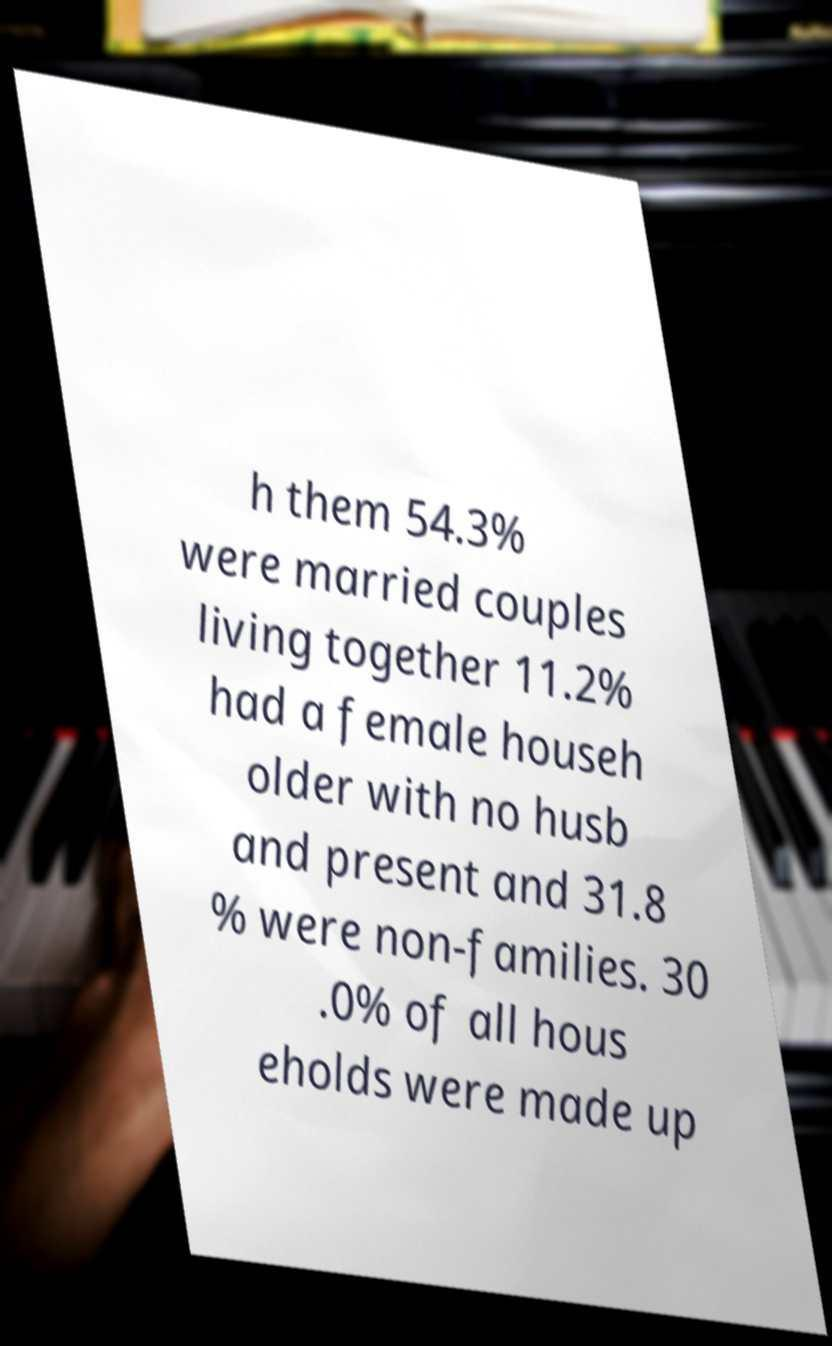Could you assist in decoding the text presented in this image and type it out clearly? h them 54.3% were married couples living together 11.2% had a female househ older with no husb and present and 31.8 % were non-families. 30 .0% of all hous eholds were made up 